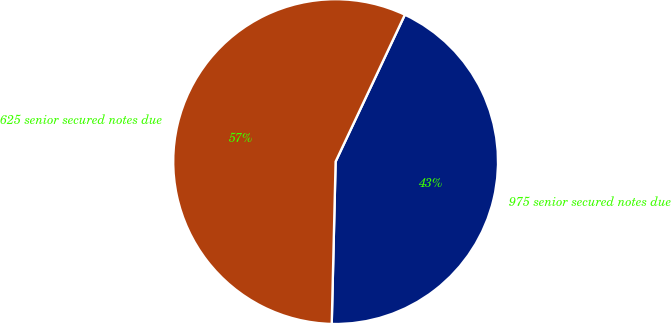Convert chart to OTSL. <chart><loc_0><loc_0><loc_500><loc_500><pie_chart><fcel>975 senior secured notes due<fcel>625 senior secured notes due<nl><fcel>43.37%<fcel>56.63%<nl></chart> 